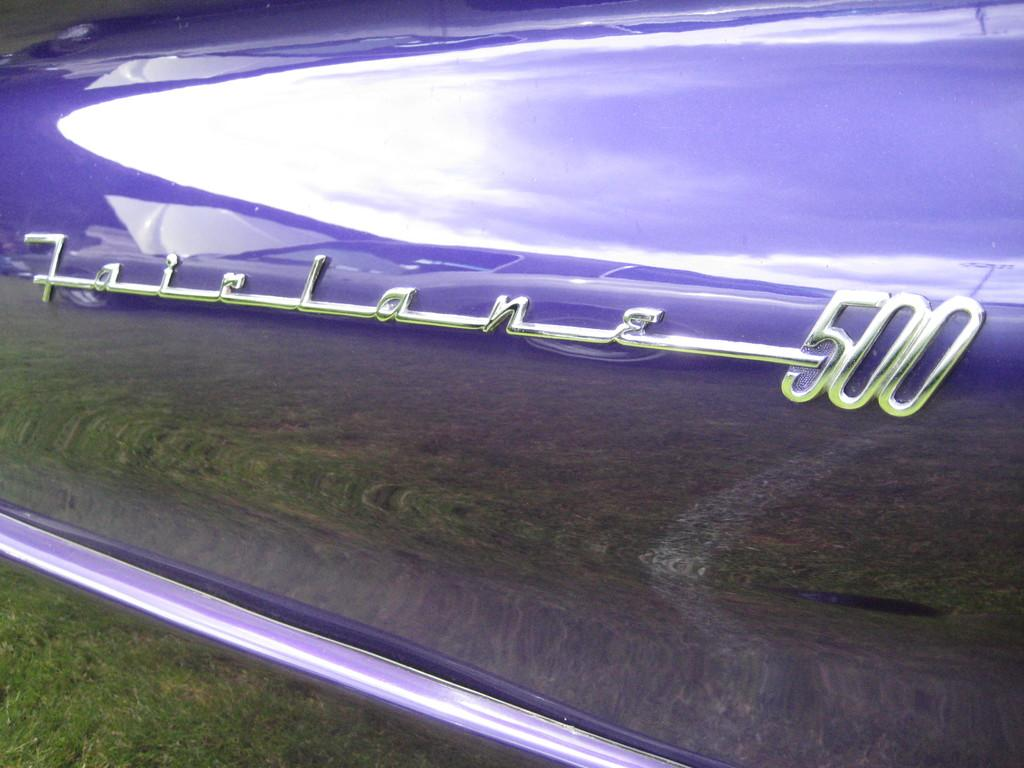What information about the car can be seen in the image? The name and model of the car are visible in the image. What type of surface is at the bottom of the image? There is grass on the surface at the bottom of the image. What type of cheese is being used to clean the car in the image? There is no cheese present in the image, and the car is not being cleaned. 